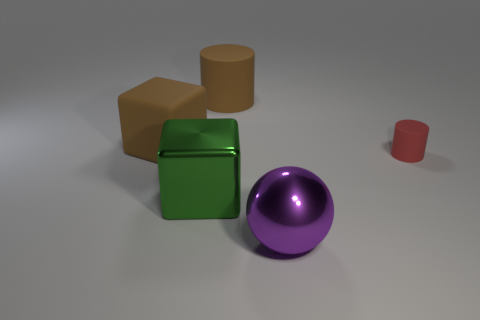Add 1 tiny blue metal things. How many objects exist? 6 Subtract all spheres. How many objects are left? 4 Add 2 yellow rubber blocks. How many yellow rubber blocks exist? 2 Subtract 1 brown cylinders. How many objects are left? 4 Subtract all large brown things. Subtract all green metal objects. How many objects are left? 2 Add 3 brown rubber cubes. How many brown rubber cubes are left? 4 